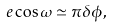Convert formula to latex. <formula><loc_0><loc_0><loc_500><loc_500>e \cos \omega \simeq \pi \delta \phi ,</formula> 